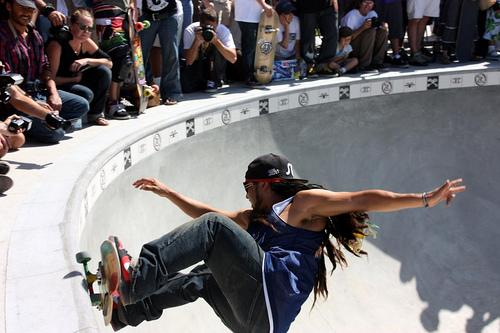What is the person in the foreground doing?

Choices:
A) fishing
B) running
C) skateboarding
D) eating skateboarding 